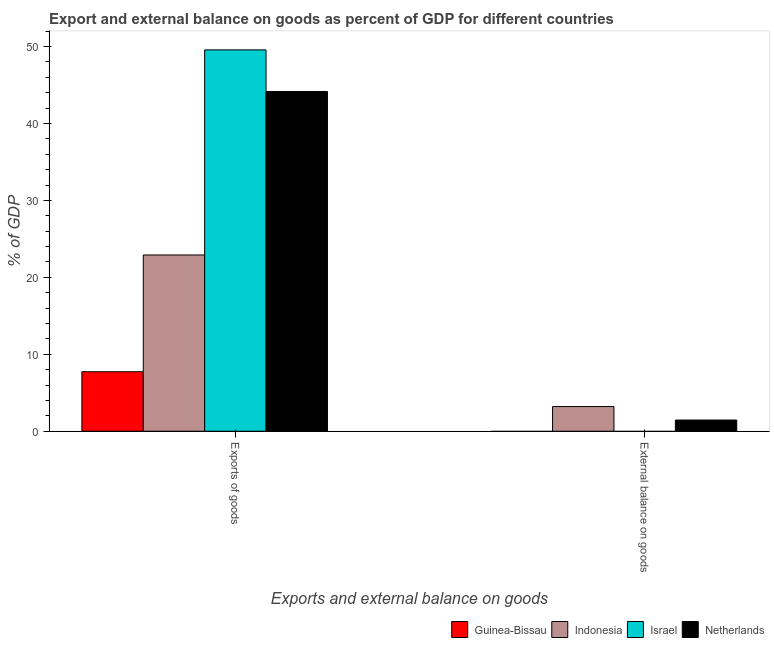How many bars are there on the 2nd tick from the right?
Make the answer very short. 4. What is the label of the 1st group of bars from the left?
Your answer should be very brief. Exports of goods. What is the export of goods as percentage of gdp in Guinea-Bissau?
Offer a very short reply. 7.73. Across all countries, what is the maximum external balance on goods as percentage of gdp?
Ensure brevity in your answer.  3.21. Across all countries, what is the minimum export of goods as percentage of gdp?
Offer a terse response. 7.73. In which country was the export of goods as percentage of gdp maximum?
Offer a terse response. Israel. What is the total external balance on goods as percentage of gdp in the graph?
Give a very brief answer. 4.66. What is the difference between the export of goods as percentage of gdp in Netherlands and that in Indonesia?
Your answer should be very brief. 21.25. What is the difference between the export of goods as percentage of gdp in Indonesia and the external balance on goods as percentage of gdp in Guinea-Bissau?
Keep it short and to the point. 22.91. What is the average external balance on goods as percentage of gdp per country?
Ensure brevity in your answer.  1.17. What is the difference between the export of goods as percentage of gdp and external balance on goods as percentage of gdp in Netherlands?
Ensure brevity in your answer.  42.71. What is the ratio of the export of goods as percentage of gdp in Guinea-Bissau to that in Indonesia?
Keep it short and to the point. 0.34. In how many countries, is the external balance on goods as percentage of gdp greater than the average external balance on goods as percentage of gdp taken over all countries?
Your answer should be compact. 2. Are all the bars in the graph horizontal?
Make the answer very short. No. How many countries are there in the graph?
Provide a short and direct response. 4. What is the difference between two consecutive major ticks on the Y-axis?
Your answer should be very brief. 10. Does the graph contain grids?
Keep it short and to the point. No. Where does the legend appear in the graph?
Give a very brief answer. Bottom right. How many legend labels are there?
Offer a very short reply. 4. How are the legend labels stacked?
Ensure brevity in your answer.  Horizontal. What is the title of the graph?
Make the answer very short. Export and external balance on goods as percent of GDP for different countries. Does "Albania" appear as one of the legend labels in the graph?
Your answer should be compact. No. What is the label or title of the X-axis?
Your response must be concise. Exports and external balance on goods. What is the label or title of the Y-axis?
Make the answer very short. % of GDP. What is the % of GDP of Guinea-Bissau in Exports of goods?
Your answer should be compact. 7.73. What is the % of GDP of Indonesia in Exports of goods?
Make the answer very short. 22.91. What is the % of GDP in Israel in Exports of goods?
Offer a terse response. 49.57. What is the % of GDP in Netherlands in Exports of goods?
Offer a very short reply. 44.16. What is the % of GDP in Guinea-Bissau in External balance on goods?
Keep it short and to the point. 0. What is the % of GDP in Indonesia in External balance on goods?
Provide a succinct answer. 3.21. What is the % of GDP of Israel in External balance on goods?
Offer a terse response. 0. What is the % of GDP of Netherlands in External balance on goods?
Your answer should be compact. 1.45. Across all Exports and external balance on goods, what is the maximum % of GDP of Guinea-Bissau?
Provide a short and direct response. 7.73. Across all Exports and external balance on goods, what is the maximum % of GDP in Indonesia?
Offer a very short reply. 22.91. Across all Exports and external balance on goods, what is the maximum % of GDP of Israel?
Your answer should be compact. 49.57. Across all Exports and external balance on goods, what is the maximum % of GDP in Netherlands?
Make the answer very short. 44.16. Across all Exports and external balance on goods, what is the minimum % of GDP in Guinea-Bissau?
Offer a terse response. 0. Across all Exports and external balance on goods, what is the minimum % of GDP of Indonesia?
Keep it short and to the point. 3.21. Across all Exports and external balance on goods, what is the minimum % of GDP of Netherlands?
Provide a succinct answer. 1.45. What is the total % of GDP of Guinea-Bissau in the graph?
Your response must be concise. 7.73. What is the total % of GDP of Indonesia in the graph?
Offer a very short reply. 26.12. What is the total % of GDP of Israel in the graph?
Make the answer very short. 49.57. What is the total % of GDP in Netherlands in the graph?
Your response must be concise. 45.62. What is the difference between the % of GDP of Indonesia in Exports of goods and that in External balance on goods?
Give a very brief answer. 19.71. What is the difference between the % of GDP of Netherlands in Exports of goods and that in External balance on goods?
Your answer should be very brief. 42.71. What is the difference between the % of GDP of Guinea-Bissau in Exports of goods and the % of GDP of Indonesia in External balance on goods?
Ensure brevity in your answer.  4.53. What is the difference between the % of GDP in Guinea-Bissau in Exports of goods and the % of GDP in Netherlands in External balance on goods?
Ensure brevity in your answer.  6.28. What is the difference between the % of GDP in Indonesia in Exports of goods and the % of GDP in Netherlands in External balance on goods?
Provide a short and direct response. 21.46. What is the difference between the % of GDP in Israel in Exports of goods and the % of GDP in Netherlands in External balance on goods?
Provide a short and direct response. 48.12. What is the average % of GDP in Guinea-Bissau per Exports and external balance on goods?
Offer a very short reply. 3.87. What is the average % of GDP in Indonesia per Exports and external balance on goods?
Provide a short and direct response. 13.06. What is the average % of GDP of Israel per Exports and external balance on goods?
Offer a very short reply. 24.79. What is the average % of GDP of Netherlands per Exports and external balance on goods?
Your answer should be compact. 22.81. What is the difference between the % of GDP of Guinea-Bissau and % of GDP of Indonesia in Exports of goods?
Make the answer very short. -15.18. What is the difference between the % of GDP in Guinea-Bissau and % of GDP in Israel in Exports of goods?
Give a very brief answer. -41.84. What is the difference between the % of GDP in Guinea-Bissau and % of GDP in Netherlands in Exports of goods?
Provide a short and direct response. -36.43. What is the difference between the % of GDP in Indonesia and % of GDP in Israel in Exports of goods?
Your answer should be very brief. -26.66. What is the difference between the % of GDP of Indonesia and % of GDP of Netherlands in Exports of goods?
Keep it short and to the point. -21.25. What is the difference between the % of GDP of Israel and % of GDP of Netherlands in Exports of goods?
Make the answer very short. 5.41. What is the difference between the % of GDP of Indonesia and % of GDP of Netherlands in External balance on goods?
Give a very brief answer. 1.75. What is the ratio of the % of GDP in Indonesia in Exports of goods to that in External balance on goods?
Your answer should be compact. 7.15. What is the ratio of the % of GDP in Netherlands in Exports of goods to that in External balance on goods?
Provide a succinct answer. 30.38. What is the difference between the highest and the second highest % of GDP of Indonesia?
Make the answer very short. 19.71. What is the difference between the highest and the second highest % of GDP of Netherlands?
Offer a very short reply. 42.71. What is the difference between the highest and the lowest % of GDP of Guinea-Bissau?
Provide a short and direct response. 7.73. What is the difference between the highest and the lowest % of GDP of Indonesia?
Your response must be concise. 19.71. What is the difference between the highest and the lowest % of GDP of Israel?
Keep it short and to the point. 49.57. What is the difference between the highest and the lowest % of GDP in Netherlands?
Ensure brevity in your answer.  42.71. 